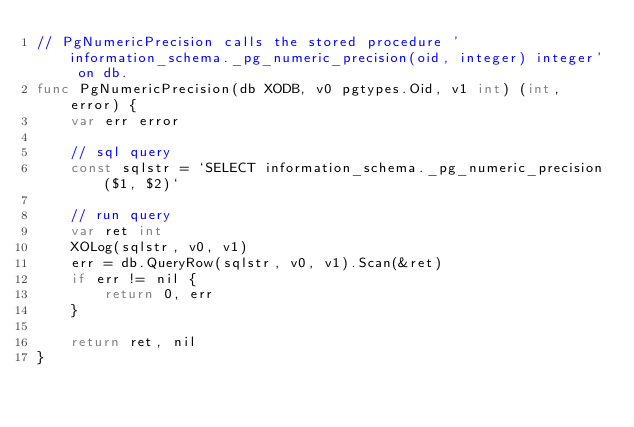<code> <loc_0><loc_0><loc_500><loc_500><_Go_>// PgNumericPrecision calls the stored procedure 'information_schema._pg_numeric_precision(oid, integer) integer' on db.
func PgNumericPrecision(db XODB, v0 pgtypes.Oid, v1 int) (int, error) {
	var err error

	// sql query
	const sqlstr = `SELECT information_schema._pg_numeric_precision($1, $2)`

	// run query
	var ret int
	XOLog(sqlstr, v0, v1)
	err = db.QueryRow(sqlstr, v0, v1).Scan(&ret)
	if err != nil {
		return 0, err
	}

	return ret, nil
}
</code> 